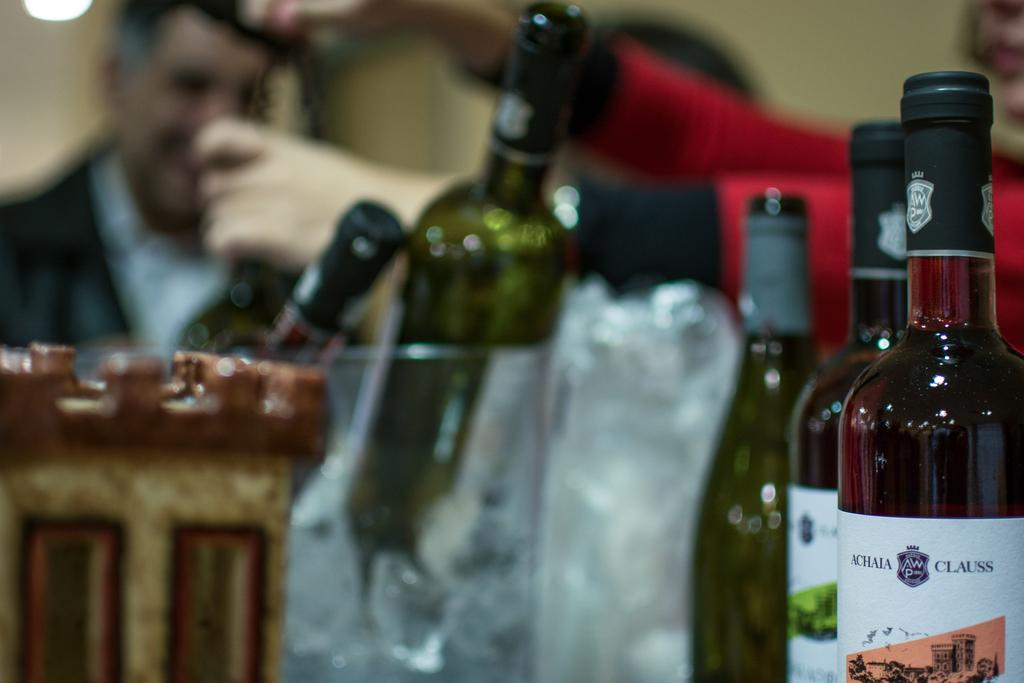Who is present in the image? There is a man in the image. What objects can be seen in the front of the image? There are bottles in the front of the image. What type of hill can be seen in the background of the image? There is no hill visible in the image; it only features a man and bottles. 